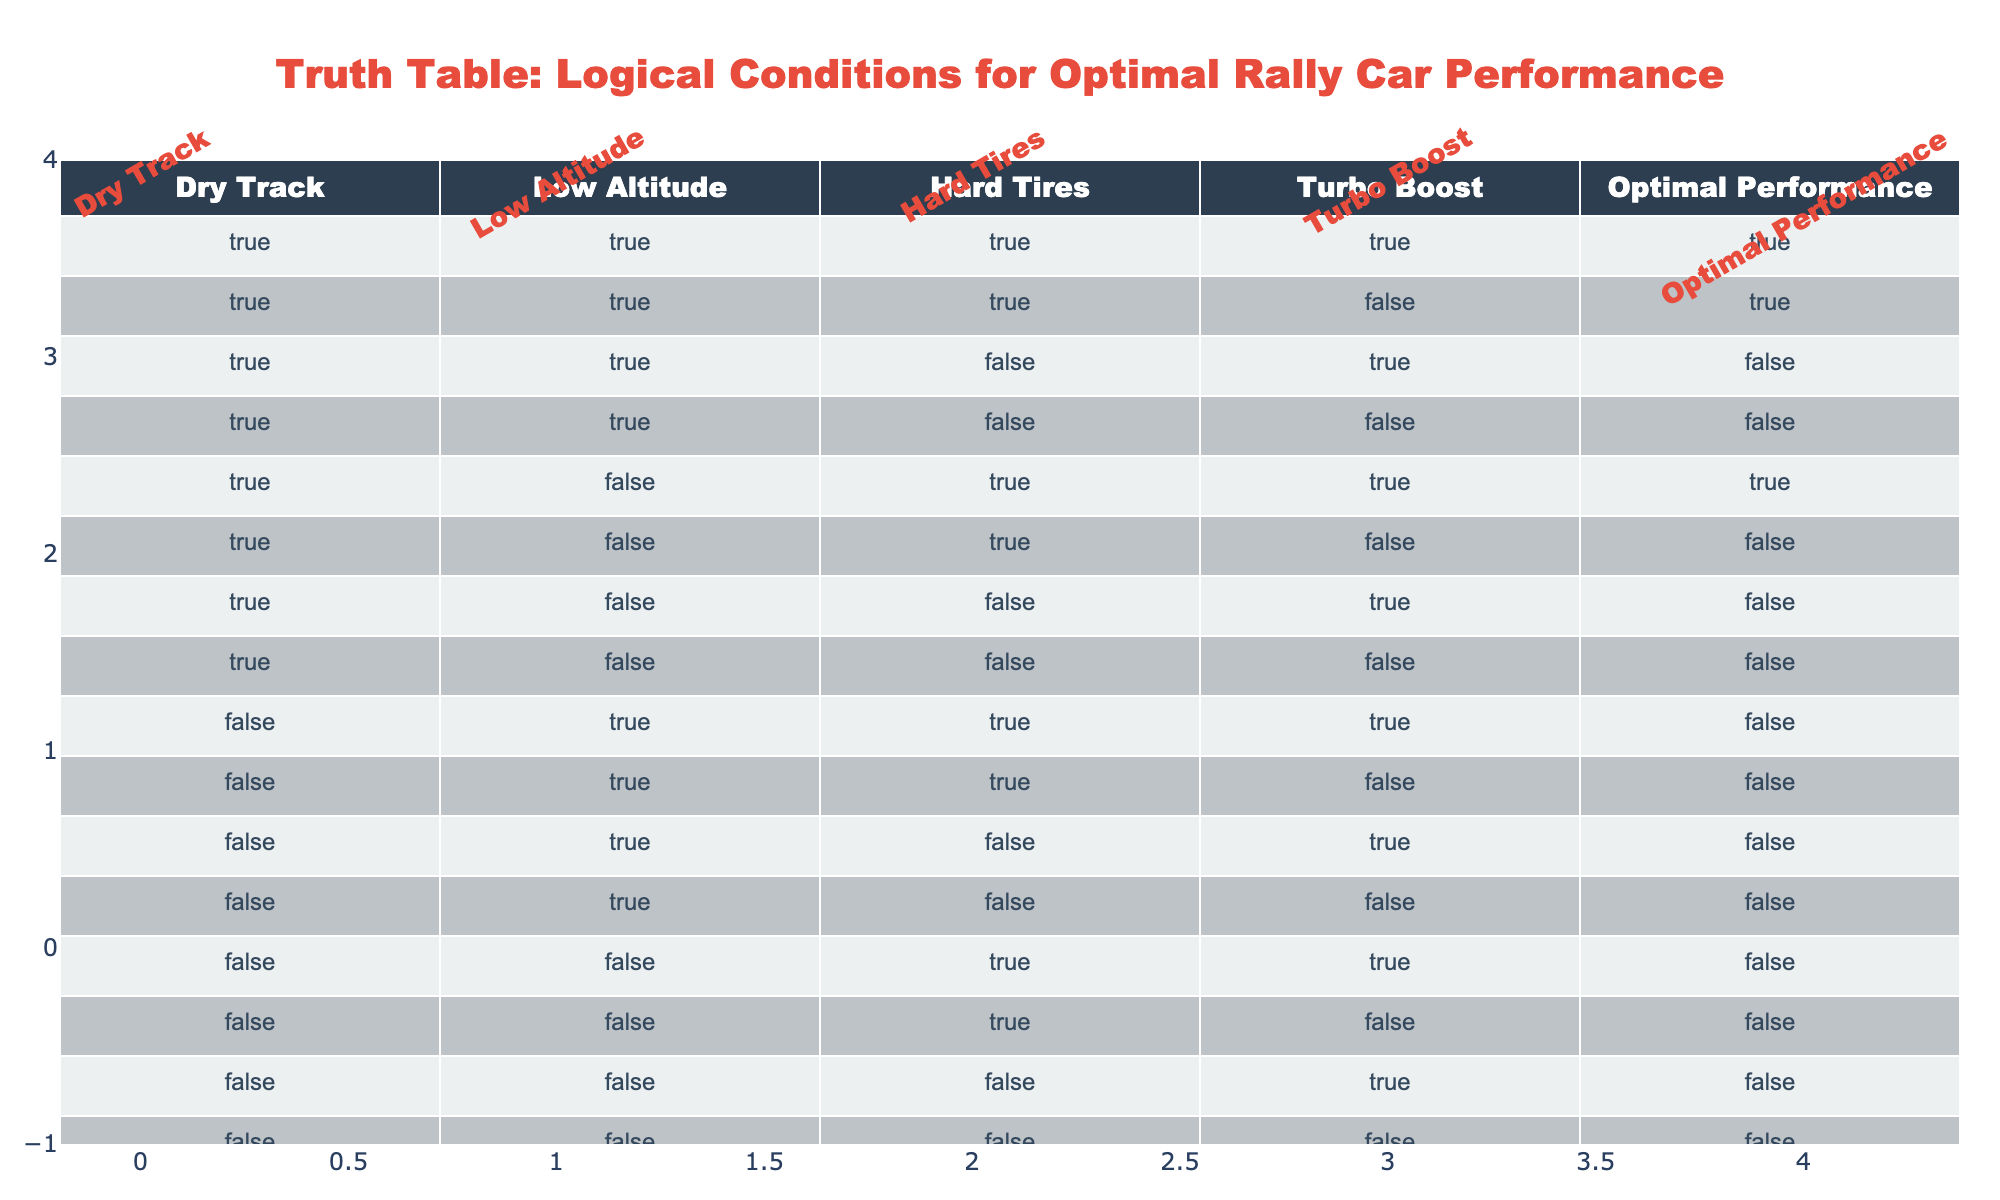What is the outcome when the track is dry and hard tires are used with turbo boost? Referring to the table, we look for the row where "Dry Track" is TRUE, "Hard Tires" is TRUE, and "Turbo Boost" is TRUE. There is one such instance (row 1) that shows "Optimal Performance" as TRUE.
Answer: TRUE How many conditions lead to optimal performance on a dry track? We check all rows where "Dry Track" is TRUE. There are 6 instances total that indicate optimal performance under those conditions.
Answer: 6 Is optimal performance achieved when the track is wet regardless of other conditions? Looking through the rows where "Dry Track" is FALSE, all resulting performances indicate FALSE for optimal performance, answering our question.
Answer: NO What combination of conditions guarantees optimal performance? The only combination that guarantees optimal performance is found in row 1, where "Dry Track," "Low Altitude," "Hard Tires," and "Turbo Boost" are all TRUE.
Answer: Dry Track, Low Altitude, Hard Tires, Turbo Boost What is the average number of conditions leading to optimal performance in low altitude situations? First, we identify rows with "Low Altitude" as TRUE, which has 8 entries. Out of these, optimal performance is only indicated from rows 1, 2, and 5—a total of 3. Thus, the average condition is 3 optimal performances out of 8 total low altitude conditions, calculated as 3/8 = 0.375.
Answer: 0.375 When turbo boost is activated, is there ever a situation with both wet track and optimal performance? Reviewing all rows with "Turbo Boost" as TRUE, we find that wet track conditions (indicated by "Dry Track" as FALSE) show "Optimal Performance" as FALSE in all cases.
Answer: NO How many instances show optimal performance with low altitude but without turbo boost? We check the rows where "Low Altitude" is TRUE and "Turbo Boost" is FALSE. There are 2 instances (rows 6 and 12) that indicate optimal performance as FALSE in both cases.
Answer: 0 If both hard tires and turbo boost are present, what is the total number of optimal performance indicators? We look for rows where both "Hard Tires" and "Turbo Boost" are TRUE and count how many of these indicate "Optimal Performance" as TRUE. There are 3 such instances (rows 1, 5, and 9).
Answer: 2 